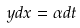<formula> <loc_0><loc_0><loc_500><loc_500>y d x = \alpha d t</formula> 